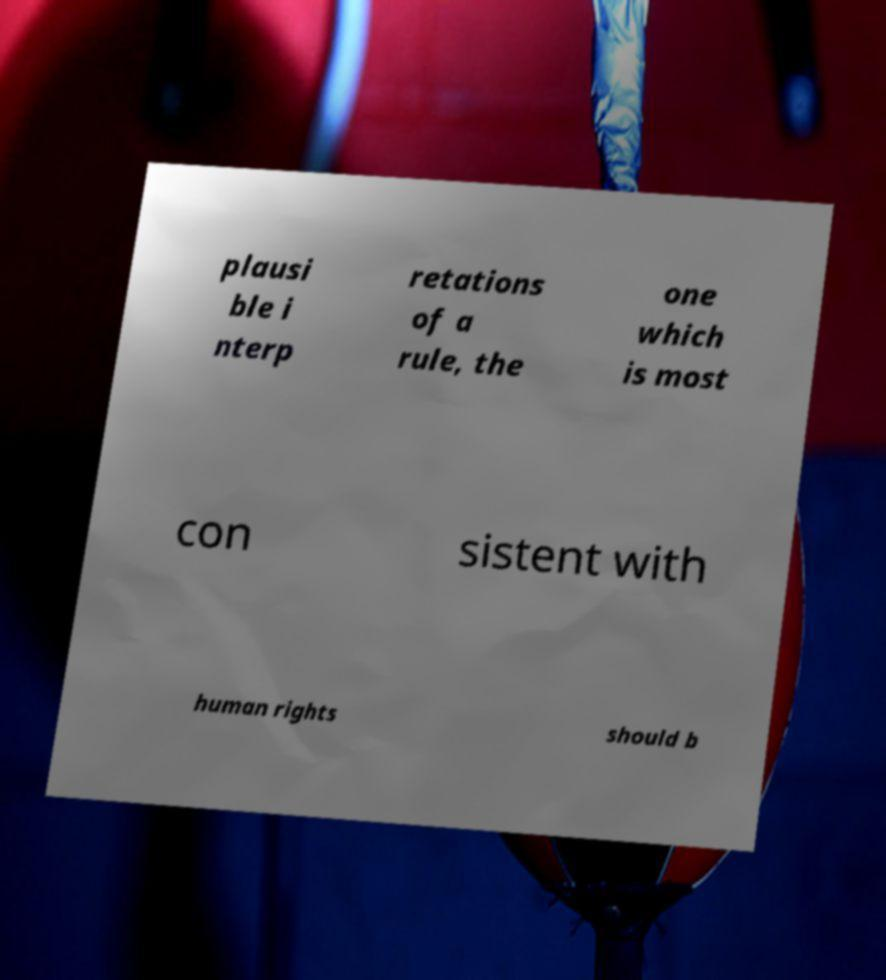Please read and relay the text visible in this image. What does it say? plausi ble i nterp retations of a rule, the one which is most con sistent with human rights should b 